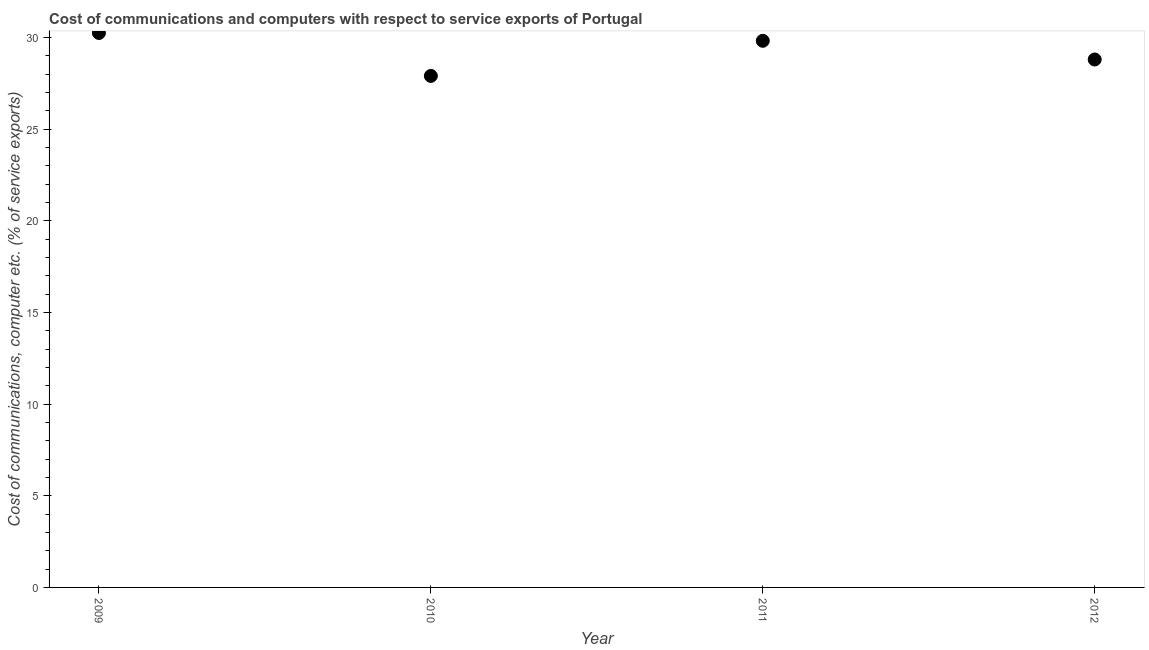What is the cost of communications and computer in 2012?
Make the answer very short. 28.8. Across all years, what is the maximum cost of communications and computer?
Provide a short and direct response. 30.25. Across all years, what is the minimum cost of communications and computer?
Ensure brevity in your answer.  27.91. In which year was the cost of communications and computer maximum?
Provide a succinct answer. 2009. In which year was the cost of communications and computer minimum?
Ensure brevity in your answer.  2010. What is the sum of the cost of communications and computer?
Ensure brevity in your answer.  116.78. What is the difference between the cost of communications and computer in 2010 and 2012?
Give a very brief answer. -0.9. What is the average cost of communications and computer per year?
Ensure brevity in your answer.  29.19. What is the median cost of communications and computer?
Offer a terse response. 29.31. What is the ratio of the cost of communications and computer in 2009 to that in 2010?
Your answer should be very brief. 1.08. What is the difference between the highest and the second highest cost of communications and computer?
Your answer should be compact. 0.43. Is the sum of the cost of communications and computer in 2010 and 2012 greater than the maximum cost of communications and computer across all years?
Give a very brief answer. Yes. What is the difference between the highest and the lowest cost of communications and computer?
Provide a short and direct response. 2.34. In how many years, is the cost of communications and computer greater than the average cost of communications and computer taken over all years?
Your answer should be very brief. 2. Does the cost of communications and computer monotonically increase over the years?
Offer a very short reply. No. Are the values on the major ticks of Y-axis written in scientific E-notation?
Keep it short and to the point. No. Does the graph contain any zero values?
Keep it short and to the point. No. Does the graph contain grids?
Keep it short and to the point. No. What is the title of the graph?
Give a very brief answer. Cost of communications and computers with respect to service exports of Portugal. What is the label or title of the Y-axis?
Provide a succinct answer. Cost of communications, computer etc. (% of service exports). What is the Cost of communications, computer etc. (% of service exports) in 2009?
Your answer should be very brief. 30.25. What is the Cost of communications, computer etc. (% of service exports) in 2010?
Your answer should be very brief. 27.91. What is the Cost of communications, computer etc. (% of service exports) in 2011?
Give a very brief answer. 29.82. What is the Cost of communications, computer etc. (% of service exports) in 2012?
Make the answer very short. 28.8. What is the difference between the Cost of communications, computer etc. (% of service exports) in 2009 and 2010?
Ensure brevity in your answer.  2.34. What is the difference between the Cost of communications, computer etc. (% of service exports) in 2009 and 2011?
Give a very brief answer. 0.43. What is the difference between the Cost of communications, computer etc. (% of service exports) in 2009 and 2012?
Your answer should be compact. 1.45. What is the difference between the Cost of communications, computer etc. (% of service exports) in 2010 and 2011?
Give a very brief answer. -1.92. What is the difference between the Cost of communications, computer etc. (% of service exports) in 2010 and 2012?
Offer a very short reply. -0.9. What is the difference between the Cost of communications, computer etc. (% of service exports) in 2011 and 2012?
Your answer should be compact. 1.02. What is the ratio of the Cost of communications, computer etc. (% of service exports) in 2009 to that in 2010?
Give a very brief answer. 1.08. What is the ratio of the Cost of communications, computer etc. (% of service exports) in 2009 to that in 2011?
Provide a succinct answer. 1.01. What is the ratio of the Cost of communications, computer etc. (% of service exports) in 2010 to that in 2011?
Provide a short and direct response. 0.94. What is the ratio of the Cost of communications, computer etc. (% of service exports) in 2011 to that in 2012?
Keep it short and to the point. 1.03. 